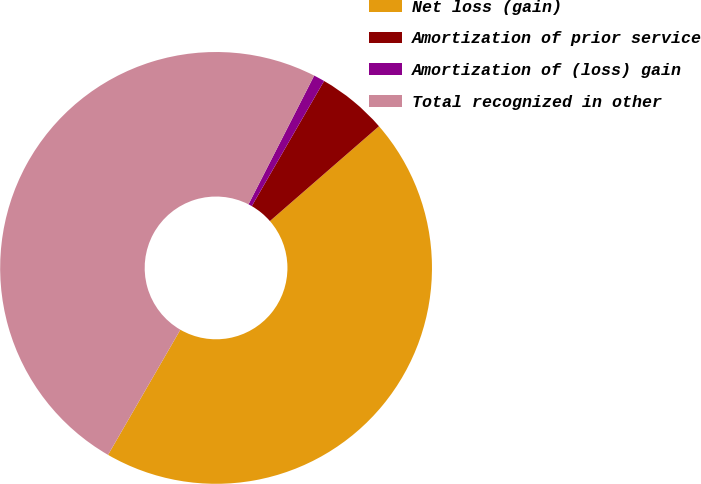<chart> <loc_0><loc_0><loc_500><loc_500><pie_chart><fcel>Net loss (gain)<fcel>Amortization of prior service<fcel>Amortization of (loss) gain<fcel>Total recognized in other<nl><fcel>44.73%<fcel>5.27%<fcel>0.83%<fcel>49.17%<nl></chart> 